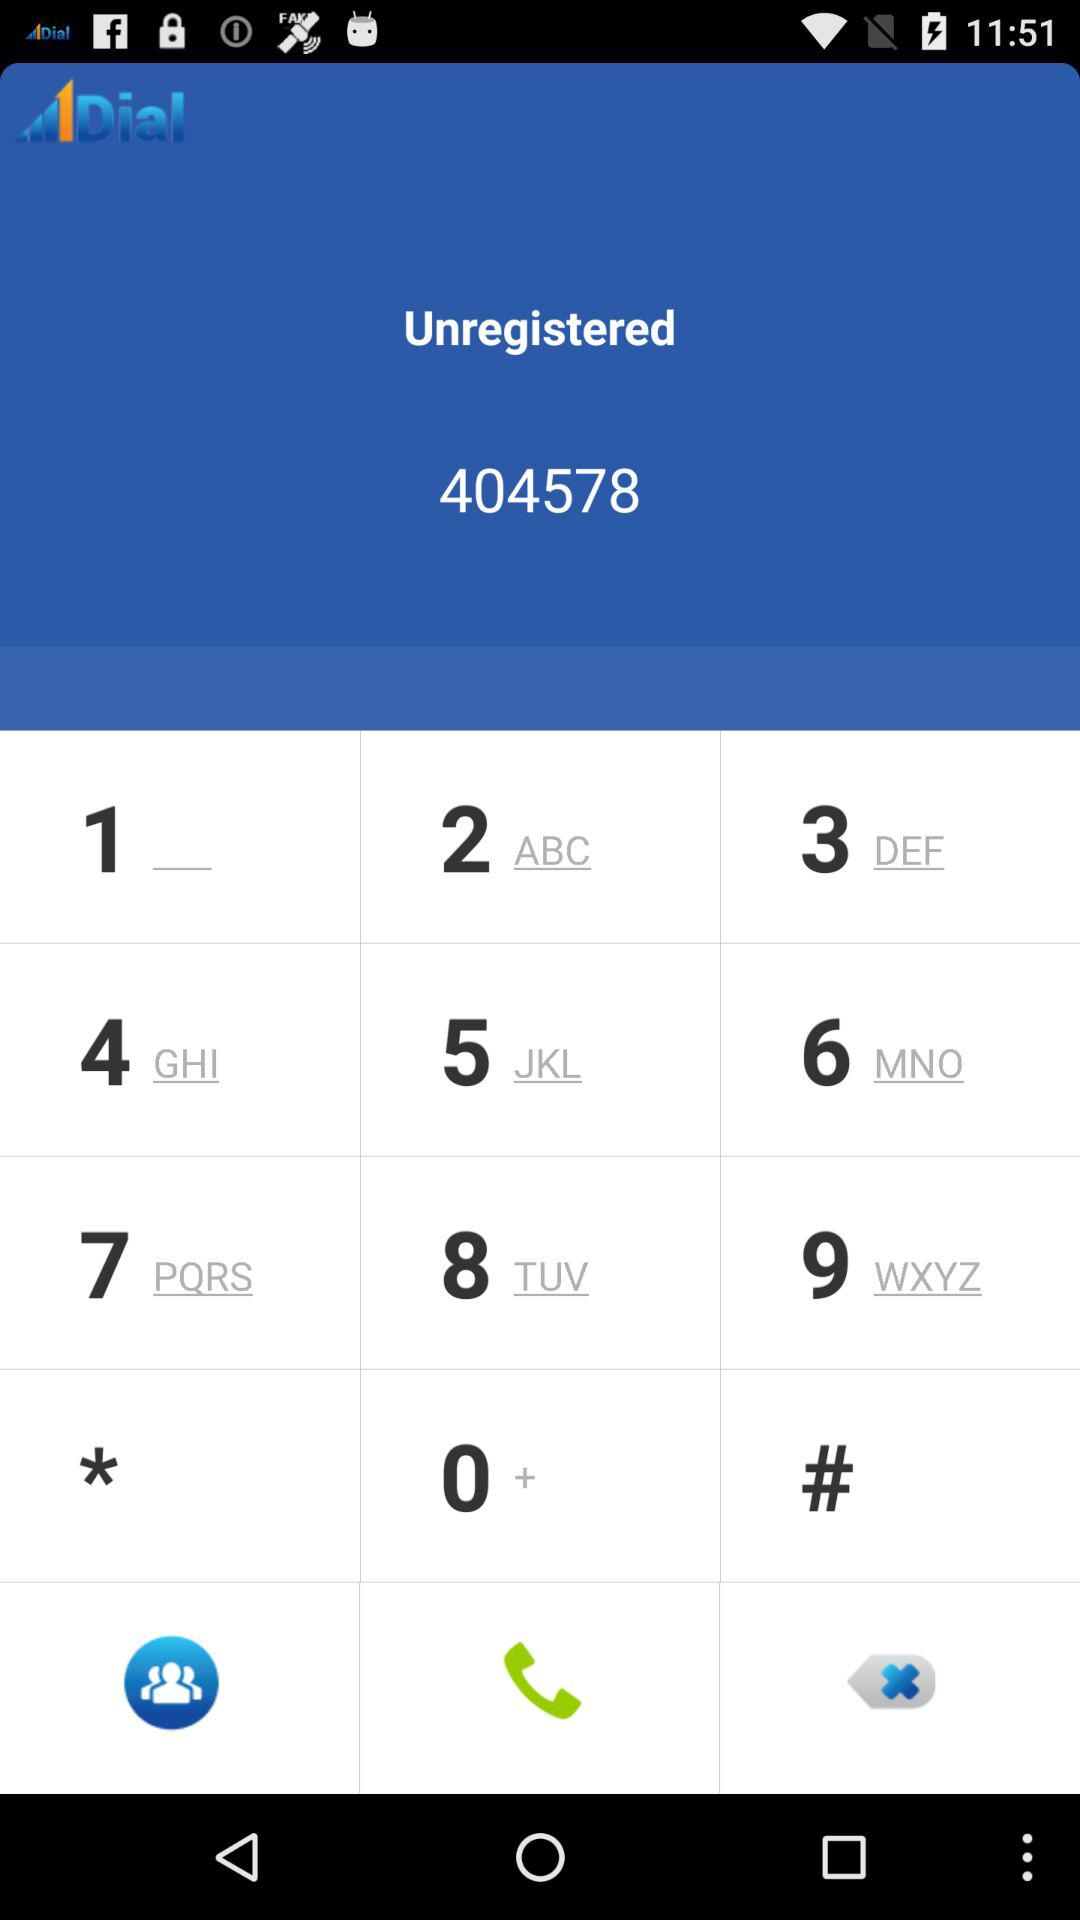What is the number that was dialed? The number that was dialed is 404578. 